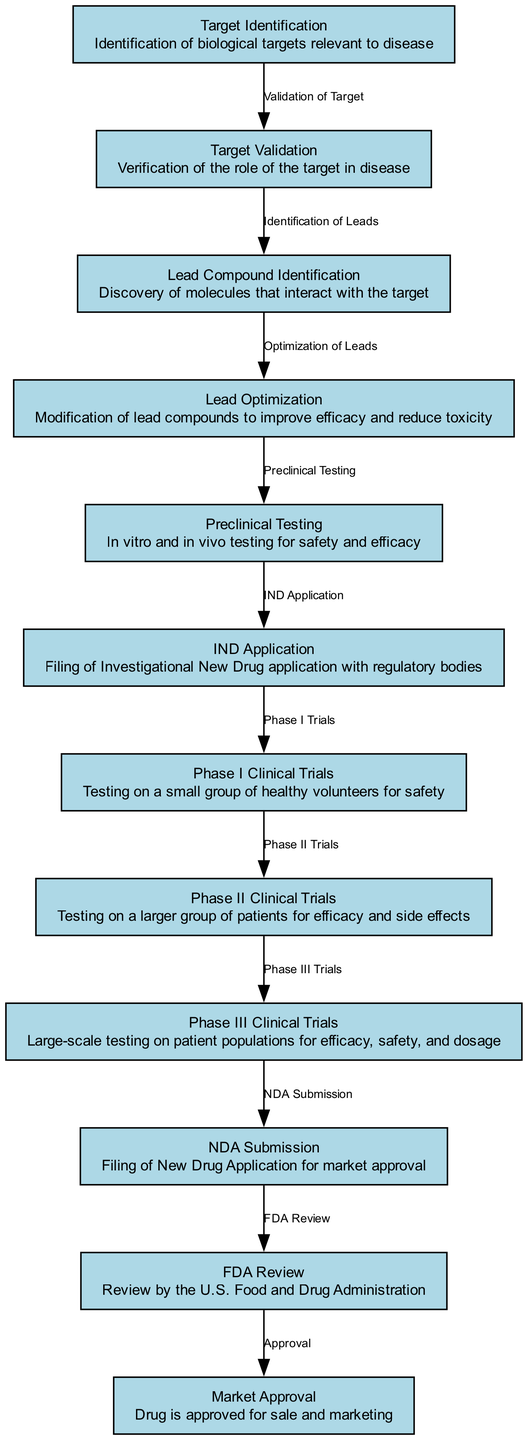What is the first stage in the drug discovery process? The diagram starts with the "Target Identification" node, which is the first stage outlined in the process flowchart.
Answer: Target Identification How many total stages are represented in the diagram? By counting the nodes in the flowchart, there are twelve distinct stages that illustrate the drug discovery process.
Answer: 12 What follows phase I clinical trials? According to the directed edges shown in the diagram, "Phase II Clinical Trials" comes immediately after "Phase I Clinical Trials."
Answer: Phase II Clinical Trials What is the purpose of the IND application stage? The "IND Application" node is defined in the diagram as the submission of an Investigational New Drug application for regulatory review, thus indicating its purpose.
Answer: Filing of Investigational New Drug application What is the final outcome in the drug discovery process according to the flowchart? Tracing the final edge in the diagram, it leads to the "Market Approval" node, which is the end result of the entire drug discovery process.
Answer: Market Approval What is the connection between Target Validation and Lead Compound Identification? The relationship is described by the edge labeled "Identification of Leads," indicating the specific process that follows target validation.
Answer: Identification of Leads Which stage includes in vitro and in vivo testing? The node labeled "Preclinical Testing" signifies that this stage encompasses both in vitro and in vivo testing for drug safety and efficacy.
Answer: Preclinical Testing How does the drug approval process begin after preclinical testing? From the "Preclinical Testing" node, the next step in the flowchart is labeled "IND Application," indicating that this is how the approval process begins.
Answer: IND Application What regulatory body reviews the NDA submission? According to the diagram, the "FDA Review" node indicates that the U.S. Food and Drug Administration is responsible for reviewing the NDA submission.
Answer: U.S. Food and Drug Administration 